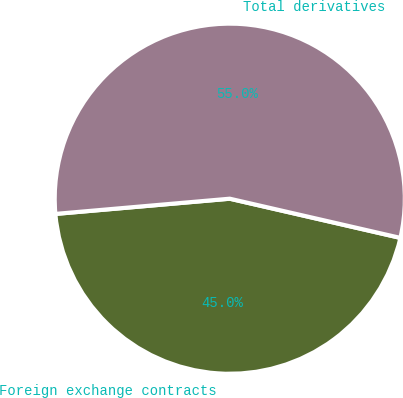Convert chart. <chart><loc_0><loc_0><loc_500><loc_500><pie_chart><fcel>Foreign exchange contracts<fcel>Total derivatives<nl><fcel>45.02%<fcel>54.98%<nl></chart> 